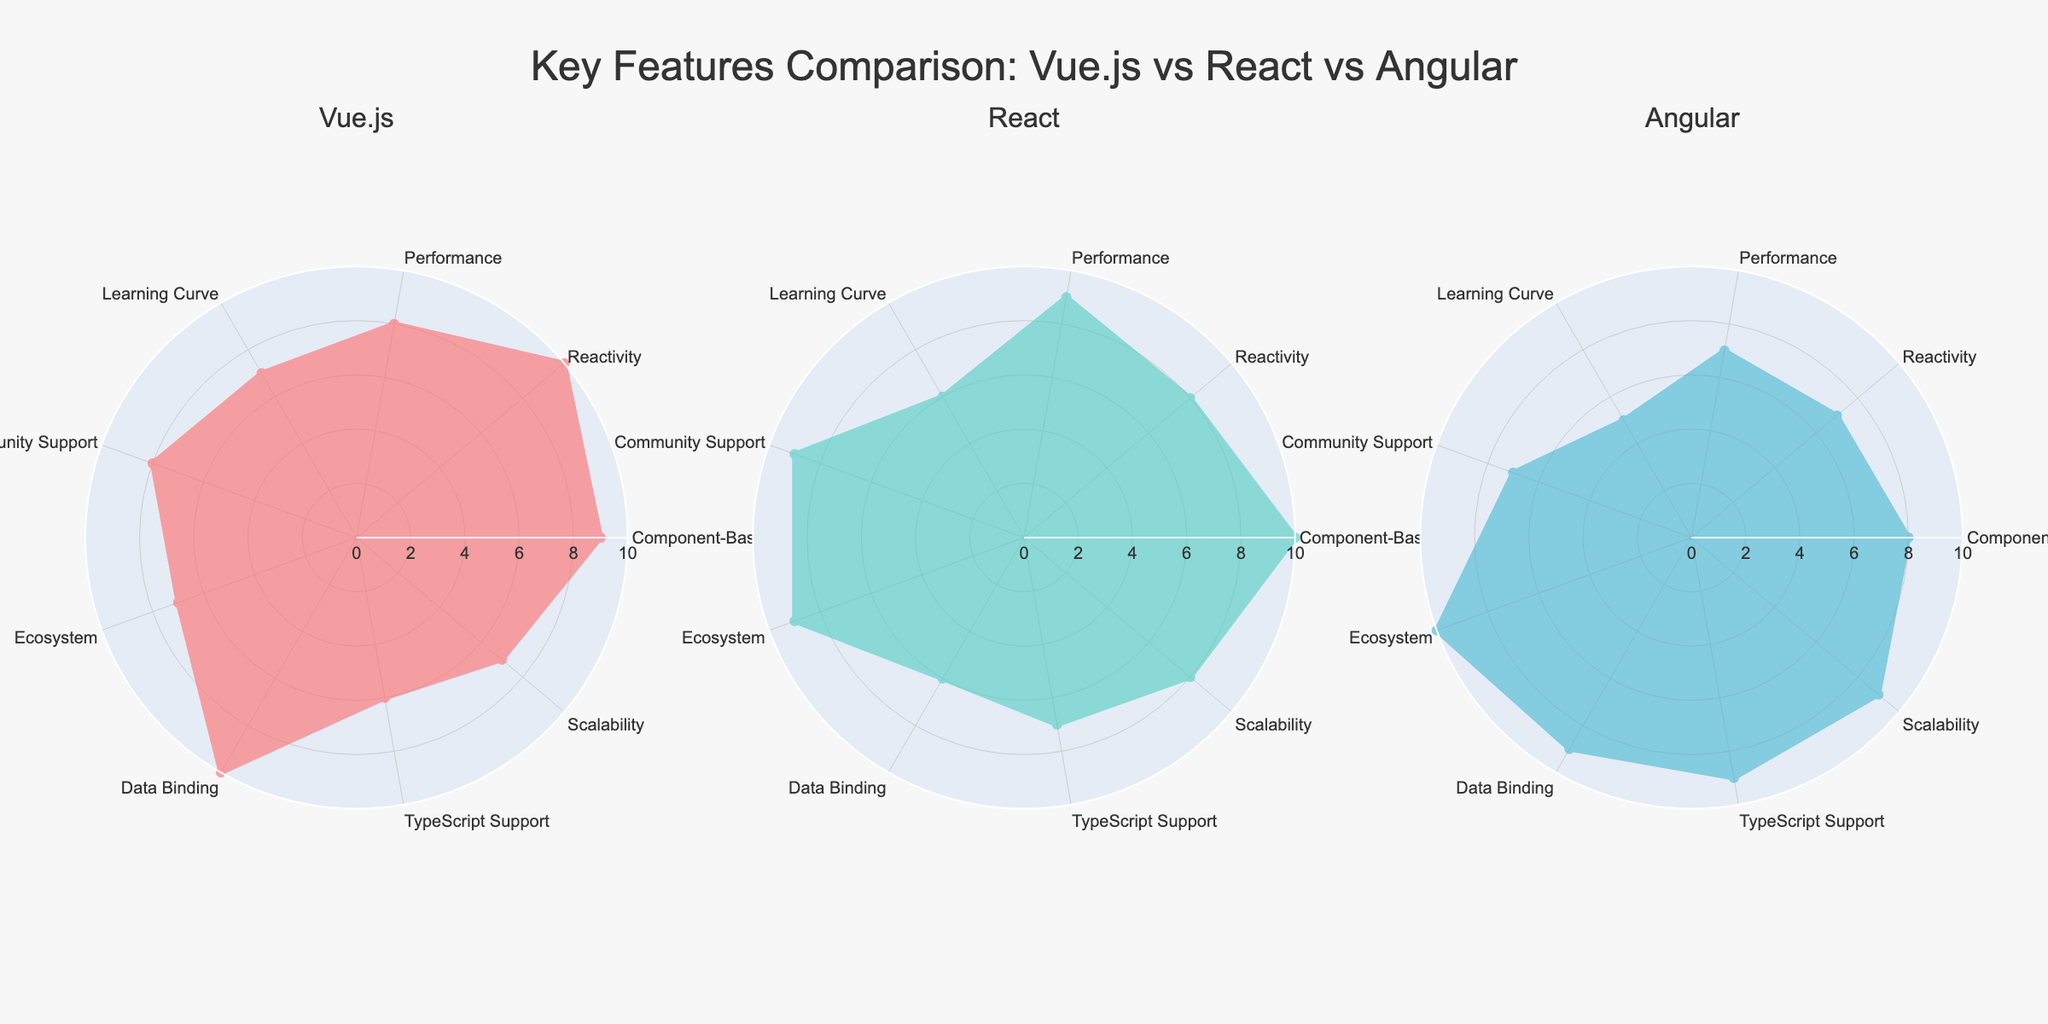What's the overall title of the figure? The title is prominently displayed at the top of the figure. It reads "Key Features Comparison: Vue.js vs React vs Angular".
Answer: "Key Features Comparison: Vue.js vs React vs Angular" Which framework shows the highest score in TypeScript Support? By looking at the 'TypeScript Support' axis, we can observe that Angular has the highest value, which is 9.
Answer: Angular How many different features are compared for each framework? The radar charts have an equal number of axes representing different features. By counting the categories listed, we see there are 9.
Answer: 9 Which framework has the highest score in Reactivity? Vue.js has the highest score in Reactivity, with a score of 10.
Answer: Vue.js Compare the Performance score between Vue.js and React. Which one is higher? By looking at the 'Performance' axis, we observe that React has a score of 9, which is higher than Vue.js’s score of 8.
Answer: React What's the average score of Community Support across all three frameworks? Summing up the 'Community Support' scores for Vue.js (8), React (9), and Angular (7) gives us 24. Dividing 24 by the number of frameworks (3) results in 8.
Answer: 8 What is the total score for Vue.js across all features? Adding up all the values for Vue.js: 9 + 10 + 8 + 7 + 8 + 7 + 10 + 6 + 7 = 72.
Answer: 72 Which framework has the lowest value in Learning Curve? By looking at the 'Learning Curve' axis, we observe that Angular has the lowest value, which is 5.
Answer: Angular Which frameworks have the same score in Component-Based Architecture? Both Vue.js and Angular have a Component-Based Architecture score of 8.
Answer: Vue.js and Angular Does Angular have a higher score in Ecosystem than Vue.js? Yes, by comparing the 'Ecosystem' scores, Angular has a score of 10, which is higher than Vue.js’s score of 7.
Answer: Yes 